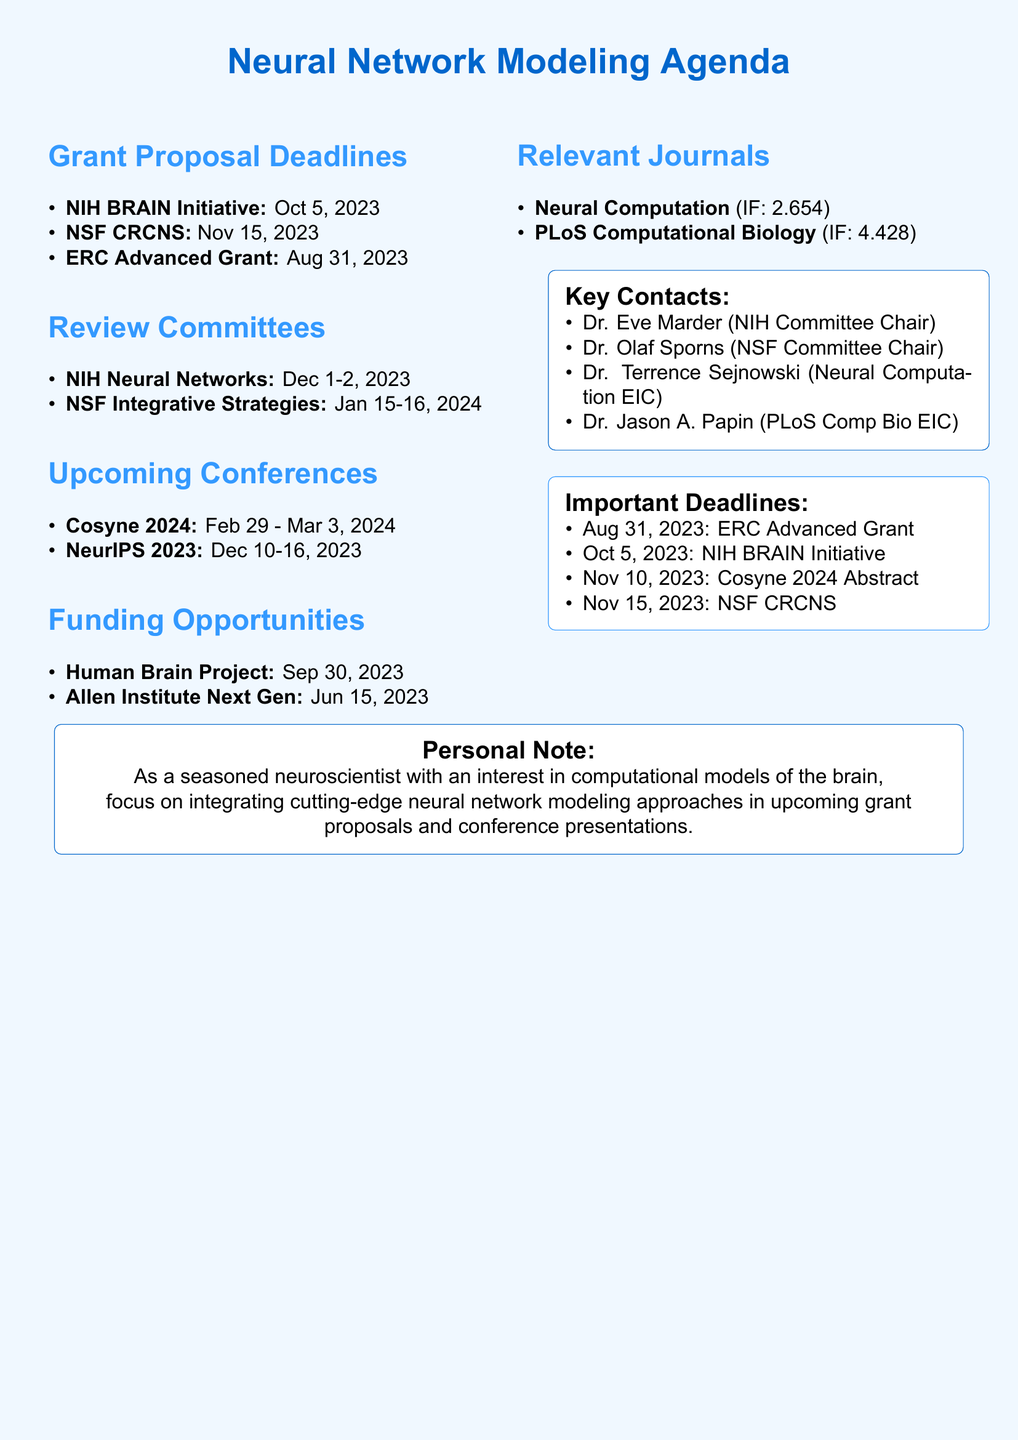what is the deadline for the NIH BRAIN Initiative? The deadline for the NIH BRAIN Initiative is listed in the grant proposal deadlines section as October 5, 2023.
Answer: October 5, 2023 who is the chair of the NIH Neural Networks and Computation Study Section? The chair's name is provided in the review committee assignments as Dr. Eve Marder.
Answer: Dr. Eve Marder what is the impact factor of PLoS Computational Biology? The impact factor is stated next to the journal name in the relevant journals section as 4.428.
Answer: 4.428 when does the upcoming conference Cosyne 2024 take place? The dates for Cosyne 2024 are detailed in the upcoming conferences section as February 29 - March 3, 2024.
Answer: February 29 - March 3, 2024 which agency has a proposal due on November 15, 2023? The agency associated with this deadline is mentioned in the grant proposal deadlines as the National Science Foundation (NSF).
Answer: National Science Foundation (NSF) how many members are there in the NIH conference committee? The number of members is found in the review committee assignments section, which lists three members.
Answer: Three what is the main focus of the Human Brain Project Partnering Project? The focus is specified in the funding opportunities section as multi-scale models of brain circuits.
Answer: Multi-scale models of brain circuits who is the editor-in-chief of Neural Computation? The editor's name is provided in the relevant journals section as Terrence J. Sejnowski.
Answer: Terrence J. Sejnowski what is the submission guideline URL for Neural Computation? The URL for the submission guidelines is listed in the relevant journals section.
Answer: https://direct.mit.edu/neco/pages/Author_Guidelines 